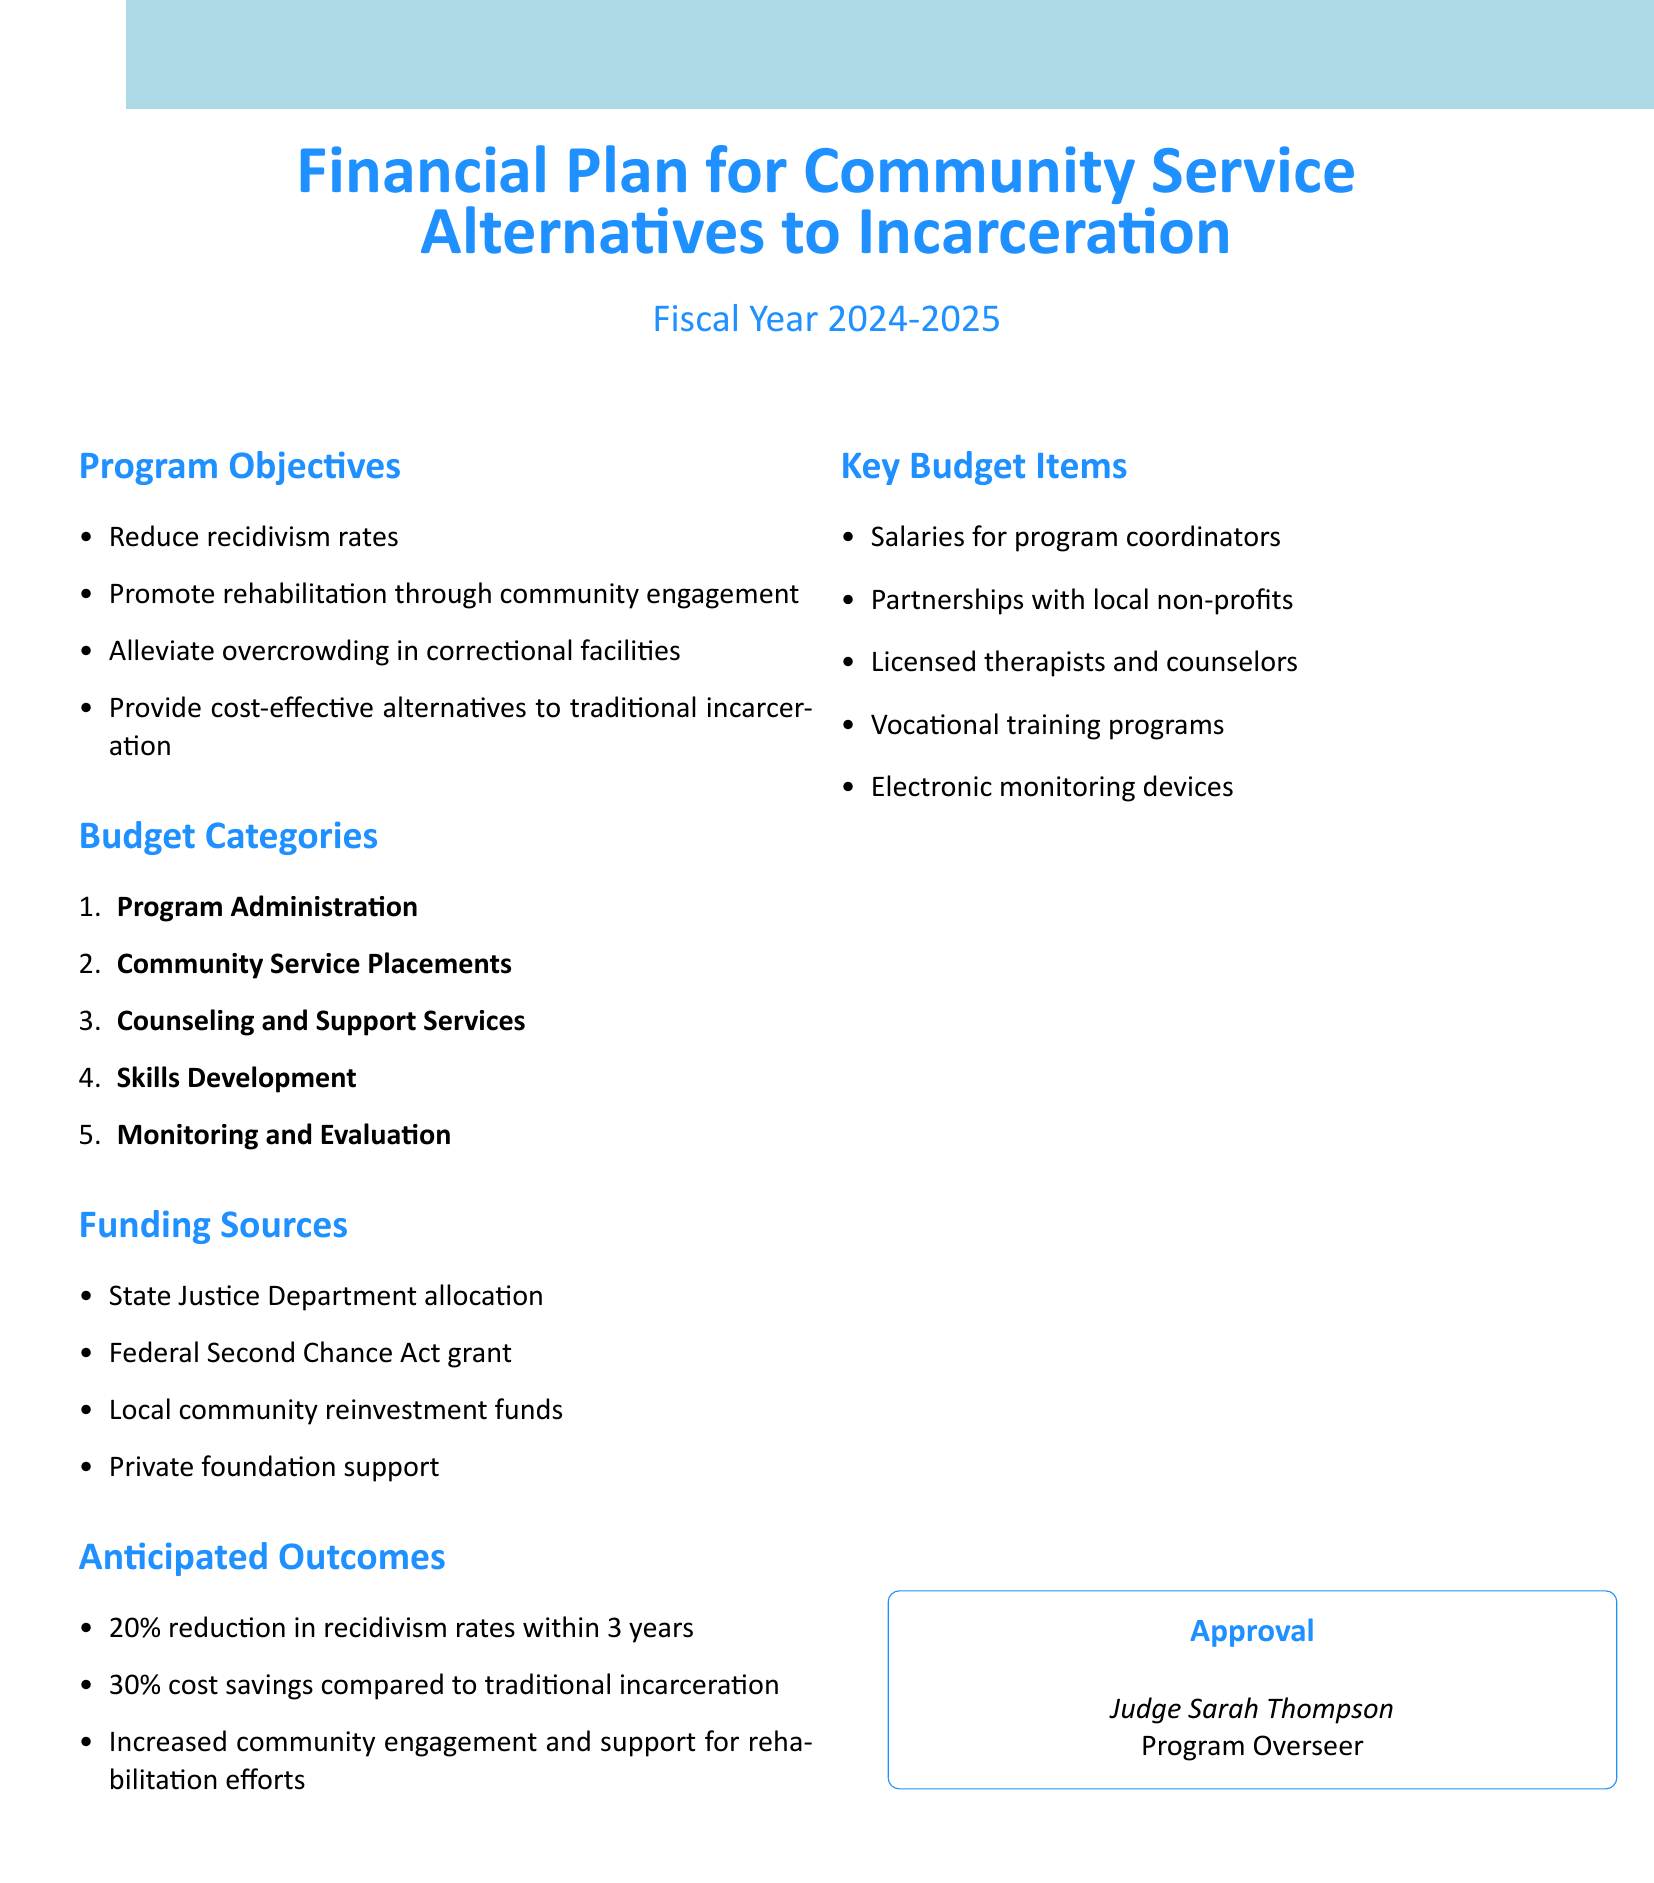what are the program objectives? The program objectives are listed in the document under "Program Objectives," including reducing recidivism rates and promoting rehabilitation.
Answer: Reduce recidivism rates, promote rehabilitation through community engagement, alleviate overcrowding in correctional facilities, provide cost-effective alternatives to traditional incarceration what is the fiscal year for the budget? The document specifies the fiscal year for the budget at the beginning.
Answer: 2024-2025 who oversees the program? The document provides the name and title of the program overseer at the bottom.
Answer: Judge Sarah Thompson what is one funding source mentioned? The funding sources are listed under "Funding Sources," with various options provided.
Answer: State Justice Department allocation what is the anticipated reduction in recidivism rates within 3 years? This information is found under "Anticipated Outcomes" where specific percentages are mentioned.
Answer: 20% how much cost savings is anticipated compared to traditional incarceration? The anticipated cost savings is indicated in the "Anticipated Outcomes" section of the document.
Answer: 30% what is one key budget item listed? The document outlines key budget items under "Key Budget Items."
Answer: Salaries for program coordinators which category includes counseling services? The budget categories describe various services, including counseling.
Answer: Counseling and Support Services 